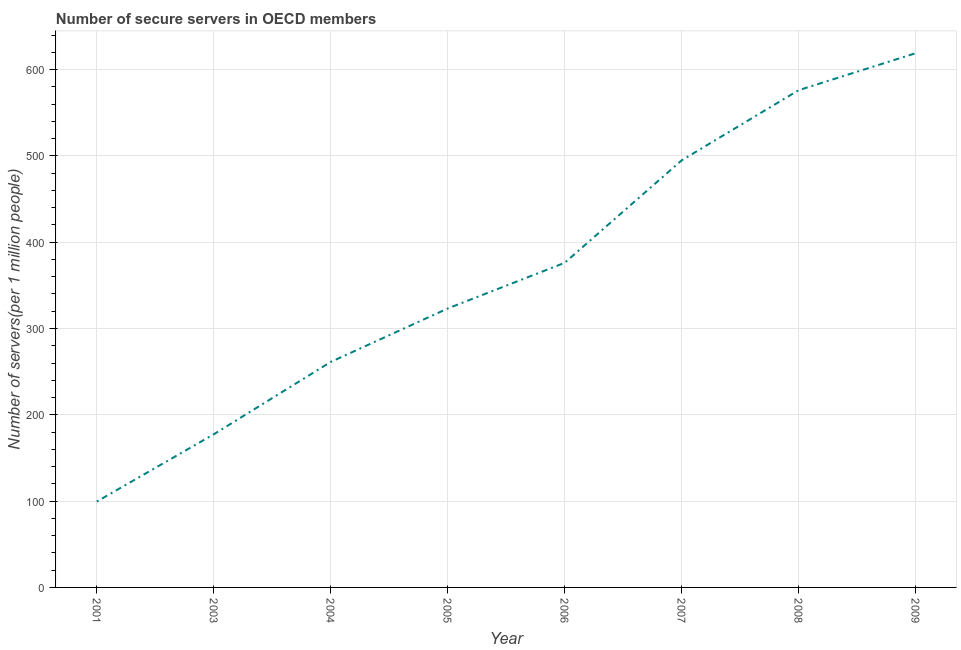What is the number of secure internet servers in 2006?
Provide a succinct answer. 376.08. Across all years, what is the maximum number of secure internet servers?
Your answer should be compact. 618.91. Across all years, what is the minimum number of secure internet servers?
Keep it short and to the point. 99.52. In which year was the number of secure internet servers maximum?
Offer a very short reply. 2009. What is the sum of the number of secure internet servers?
Make the answer very short. 2927.19. What is the difference between the number of secure internet servers in 2004 and 2005?
Your response must be concise. -61.91. What is the average number of secure internet servers per year?
Provide a short and direct response. 365.9. What is the median number of secure internet servers?
Offer a very short reply. 349.62. In how many years, is the number of secure internet servers greater than 320 ?
Make the answer very short. 5. Do a majority of the years between 2006 and 2007 (inclusive) have number of secure internet servers greater than 160 ?
Your response must be concise. Yes. What is the ratio of the number of secure internet servers in 2003 to that in 2005?
Make the answer very short. 0.55. What is the difference between the highest and the second highest number of secure internet servers?
Make the answer very short. 42.83. What is the difference between the highest and the lowest number of secure internet servers?
Ensure brevity in your answer.  519.39. In how many years, is the number of secure internet servers greater than the average number of secure internet servers taken over all years?
Provide a succinct answer. 4. How many lines are there?
Keep it short and to the point. 1. How many years are there in the graph?
Offer a terse response. 8. Are the values on the major ticks of Y-axis written in scientific E-notation?
Make the answer very short. No. Does the graph contain any zero values?
Make the answer very short. No. Does the graph contain grids?
Offer a very short reply. Yes. What is the title of the graph?
Ensure brevity in your answer.  Number of secure servers in OECD members. What is the label or title of the Y-axis?
Provide a short and direct response. Number of servers(per 1 million people). What is the Number of servers(per 1 million people) of 2001?
Make the answer very short. 99.52. What is the Number of servers(per 1 million people) of 2003?
Make the answer very short. 177.43. What is the Number of servers(per 1 million people) of 2004?
Offer a terse response. 261.25. What is the Number of servers(per 1 million people) in 2005?
Make the answer very short. 323.16. What is the Number of servers(per 1 million people) in 2006?
Give a very brief answer. 376.08. What is the Number of servers(per 1 million people) of 2007?
Ensure brevity in your answer.  494.79. What is the Number of servers(per 1 million people) of 2008?
Your response must be concise. 576.08. What is the Number of servers(per 1 million people) in 2009?
Give a very brief answer. 618.91. What is the difference between the Number of servers(per 1 million people) in 2001 and 2003?
Give a very brief answer. -77.91. What is the difference between the Number of servers(per 1 million people) in 2001 and 2004?
Your answer should be compact. -161.73. What is the difference between the Number of servers(per 1 million people) in 2001 and 2005?
Provide a succinct answer. -223.64. What is the difference between the Number of servers(per 1 million people) in 2001 and 2006?
Your answer should be compact. -276.56. What is the difference between the Number of servers(per 1 million people) in 2001 and 2007?
Make the answer very short. -395.27. What is the difference between the Number of servers(per 1 million people) in 2001 and 2008?
Make the answer very short. -476.56. What is the difference between the Number of servers(per 1 million people) in 2001 and 2009?
Your answer should be very brief. -519.39. What is the difference between the Number of servers(per 1 million people) in 2003 and 2004?
Keep it short and to the point. -83.82. What is the difference between the Number of servers(per 1 million people) in 2003 and 2005?
Make the answer very short. -145.73. What is the difference between the Number of servers(per 1 million people) in 2003 and 2006?
Offer a terse response. -198.65. What is the difference between the Number of servers(per 1 million people) in 2003 and 2007?
Keep it short and to the point. -317.36. What is the difference between the Number of servers(per 1 million people) in 2003 and 2008?
Keep it short and to the point. -398.65. What is the difference between the Number of servers(per 1 million people) in 2003 and 2009?
Your answer should be compact. -441.48. What is the difference between the Number of servers(per 1 million people) in 2004 and 2005?
Provide a succinct answer. -61.91. What is the difference between the Number of servers(per 1 million people) in 2004 and 2006?
Your response must be concise. -114.83. What is the difference between the Number of servers(per 1 million people) in 2004 and 2007?
Make the answer very short. -233.54. What is the difference between the Number of servers(per 1 million people) in 2004 and 2008?
Provide a succinct answer. -314.83. What is the difference between the Number of servers(per 1 million people) in 2004 and 2009?
Keep it short and to the point. -357.66. What is the difference between the Number of servers(per 1 million people) in 2005 and 2006?
Offer a terse response. -52.92. What is the difference between the Number of servers(per 1 million people) in 2005 and 2007?
Provide a short and direct response. -171.63. What is the difference between the Number of servers(per 1 million people) in 2005 and 2008?
Ensure brevity in your answer.  -252.92. What is the difference between the Number of servers(per 1 million people) in 2005 and 2009?
Keep it short and to the point. -295.75. What is the difference between the Number of servers(per 1 million people) in 2006 and 2007?
Offer a very short reply. -118.71. What is the difference between the Number of servers(per 1 million people) in 2006 and 2008?
Offer a very short reply. -200. What is the difference between the Number of servers(per 1 million people) in 2006 and 2009?
Ensure brevity in your answer.  -242.83. What is the difference between the Number of servers(per 1 million people) in 2007 and 2008?
Your answer should be very brief. -81.29. What is the difference between the Number of servers(per 1 million people) in 2007 and 2009?
Make the answer very short. -124.12. What is the difference between the Number of servers(per 1 million people) in 2008 and 2009?
Your answer should be compact. -42.83. What is the ratio of the Number of servers(per 1 million people) in 2001 to that in 2003?
Provide a succinct answer. 0.56. What is the ratio of the Number of servers(per 1 million people) in 2001 to that in 2004?
Offer a terse response. 0.38. What is the ratio of the Number of servers(per 1 million people) in 2001 to that in 2005?
Offer a very short reply. 0.31. What is the ratio of the Number of servers(per 1 million people) in 2001 to that in 2006?
Ensure brevity in your answer.  0.27. What is the ratio of the Number of servers(per 1 million people) in 2001 to that in 2007?
Make the answer very short. 0.2. What is the ratio of the Number of servers(per 1 million people) in 2001 to that in 2008?
Keep it short and to the point. 0.17. What is the ratio of the Number of servers(per 1 million people) in 2001 to that in 2009?
Offer a very short reply. 0.16. What is the ratio of the Number of servers(per 1 million people) in 2003 to that in 2004?
Provide a short and direct response. 0.68. What is the ratio of the Number of servers(per 1 million people) in 2003 to that in 2005?
Make the answer very short. 0.55. What is the ratio of the Number of servers(per 1 million people) in 2003 to that in 2006?
Keep it short and to the point. 0.47. What is the ratio of the Number of servers(per 1 million people) in 2003 to that in 2007?
Offer a terse response. 0.36. What is the ratio of the Number of servers(per 1 million people) in 2003 to that in 2008?
Your answer should be compact. 0.31. What is the ratio of the Number of servers(per 1 million people) in 2003 to that in 2009?
Make the answer very short. 0.29. What is the ratio of the Number of servers(per 1 million people) in 2004 to that in 2005?
Ensure brevity in your answer.  0.81. What is the ratio of the Number of servers(per 1 million people) in 2004 to that in 2006?
Provide a short and direct response. 0.69. What is the ratio of the Number of servers(per 1 million people) in 2004 to that in 2007?
Provide a succinct answer. 0.53. What is the ratio of the Number of servers(per 1 million people) in 2004 to that in 2008?
Provide a short and direct response. 0.45. What is the ratio of the Number of servers(per 1 million people) in 2004 to that in 2009?
Ensure brevity in your answer.  0.42. What is the ratio of the Number of servers(per 1 million people) in 2005 to that in 2006?
Provide a succinct answer. 0.86. What is the ratio of the Number of servers(per 1 million people) in 2005 to that in 2007?
Provide a succinct answer. 0.65. What is the ratio of the Number of servers(per 1 million people) in 2005 to that in 2008?
Keep it short and to the point. 0.56. What is the ratio of the Number of servers(per 1 million people) in 2005 to that in 2009?
Your response must be concise. 0.52. What is the ratio of the Number of servers(per 1 million people) in 2006 to that in 2007?
Keep it short and to the point. 0.76. What is the ratio of the Number of servers(per 1 million people) in 2006 to that in 2008?
Keep it short and to the point. 0.65. What is the ratio of the Number of servers(per 1 million people) in 2006 to that in 2009?
Offer a terse response. 0.61. What is the ratio of the Number of servers(per 1 million people) in 2007 to that in 2008?
Your response must be concise. 0.86. What is the ratio of the Number of servers(per 1 million people) in 2007 to that in 2009?
Keep it short and to the point. 0.8. 